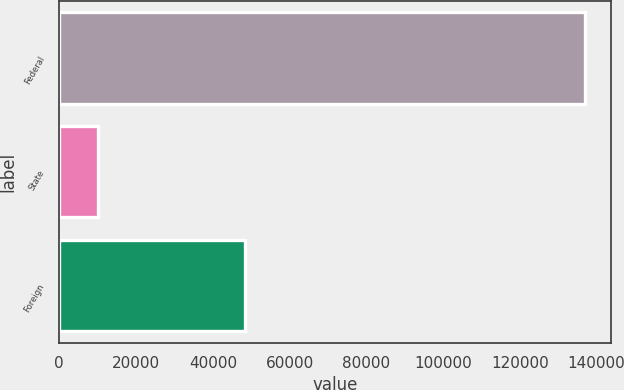Convert chart. <chart><loc_0><loc_0><loc_500><loc_500><bar_chart><fcel>Federal<fcel>State<fcel>Foreign<nl><fcel>136860<fcel>9972<fcel>48403<nl></chart> 